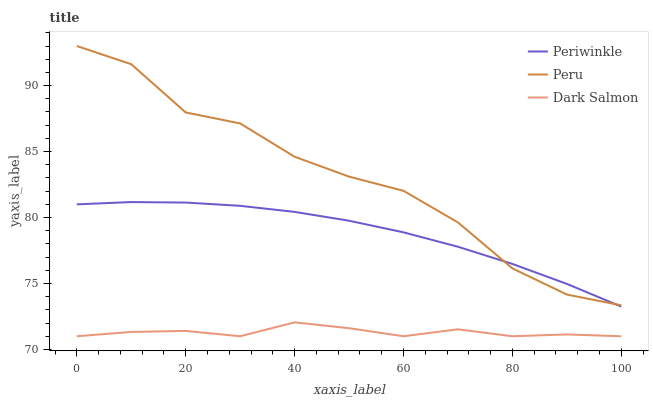Does Dark Salmon have the minimum area under the curve?
Answer yes or no. Yes. Does Peru have the maximum area under the curve?
Answer yes or no. Yes. Does Peru have the minimum area under the curve?
Answer yes or no. No. Does Dark Salmon have the maximum area under the curve?
Answer yes or no. No. Is Periwinkle the smoothest?
Answer yes or no. Yes. Is Peru the roughest?
Answer yes or no. Yes. Is Dark Salmon the smoothest?
Answer yes or no. No. Is Dark Salmon the roughest?
Answer yes or no. No. Does Peru have the lowest value?
Answer yes or no. No. Does Peru have the highest value?
Answer yes or no. Yes. Does Dark Salmon have the highest value?
Answer yes or no. No. Is Dark Salmon less than Peru?
Answer yes or no. Yes. Is Peru greater than Dark Salmon?
Answer yes or no. Yes. Does Dark Salmon intersect Peru?
Answer yes or no. No. 